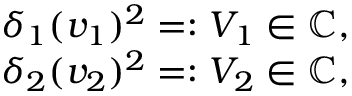Convert formula to latex. <formula><loc_0><loc_0><loc_500><loc_500>\begin{array} { r } { \delta _ { 1 } ( v _ { 1 } ) ^ { 2 } = \colon V _ { 1 } \in \mathbb { C } , } \\ { \delta _ { 2 } ( v _ { 2 } ) ^ { 2 } = \colon V _ { 2 } \in \mathbb { C } , } \end{array}</formula> 